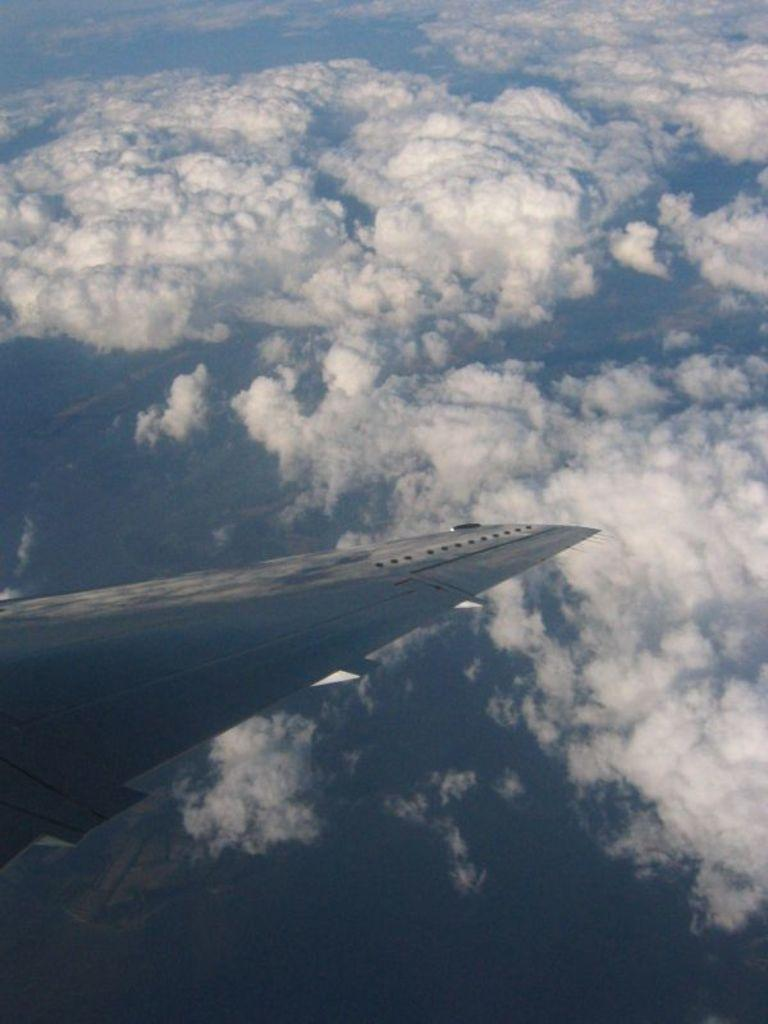What is the main subject of the picture? The main subject of the picture is an airplane wing. What can be seen in the background of the picture? The sky is visible in the background of the picture. What is the condition of the sky in the picture? Clouds are present in the sky. Can you tell me how many rabbits are hopping on the airplane wing in the image? There are no rabbits present on the airplane wing in the image. What type of father can be seen in the image? There is no father present in the image; it features an airplane wing and clouds in the sky. 